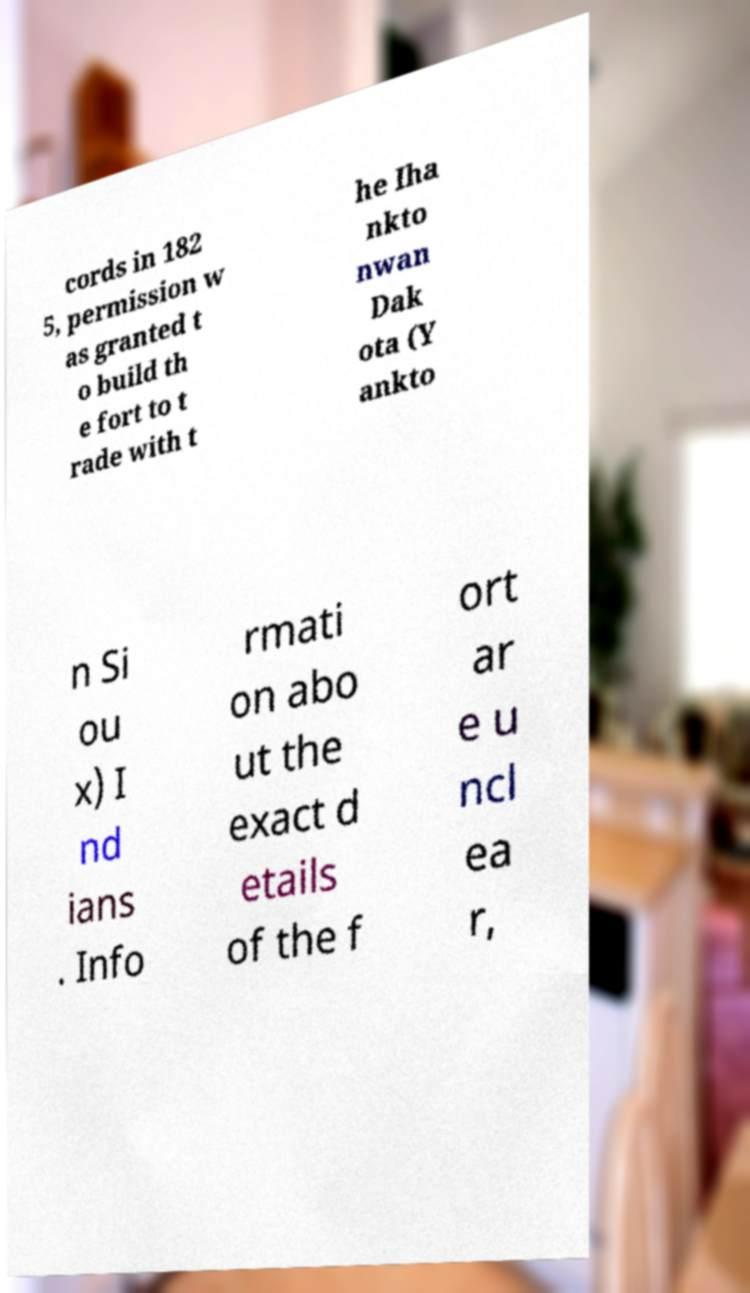Can you accurately transcribe the text from the provided image for me? cords in 182 5, permission w as granted t o build th e fort to t rade with t he Iha nkto nwan Dak ota (Y ankto n Si ou x) I nd ians . Info rmati on abo ut the exact d etails of the f ort ar e u ncl ea r, 